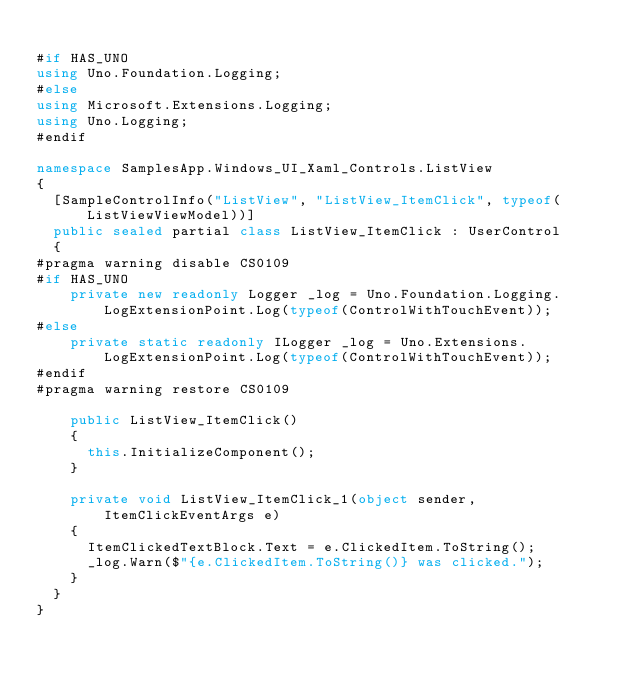<code> <loc_0><loc_0><loc_500><loc_500><_C#_>
#if HAS_UNO
using Uno.Foundation.Logging;
#else
using Microsoft.Extensions.Logging;
using Uno.Logging;
#endif

namespace SamplesApp.Windows_UI_Xaml_Controls.ListView
{
	[SampleControlInfo("ListView", "ListView_ItemClick", typeof(ListViewViewModel))]
	public sealed partial class ListView_ItemClick : UserControl
	{
#pragma warning disable CS0109
#if HAS_UNO
		private new readonly Logger _log = Uno.Foundation.Logging.LogExtensionPoint.Log(typeof(ControlWithTouchEvent));
#else
		private static readonly ILogger _log = Uno.Extensions.LogExtensionPoint.Log(typeof(ControlWithTouchEvent));
#endif
#pragma warning restore CS0109

		public ListView_ItemClick()
		{
			this.InitializeComponent();
		}

		private void ListView_ItemClick_1(object sender, ItemClickEventArgs e)
		{
			ItemClickedTextBlock.Text = e.ClickedItem.ToString();
			_log.Warn($"{e.ClickedItem.ToString()} was clicked.");
		}
	}
}
</code> 